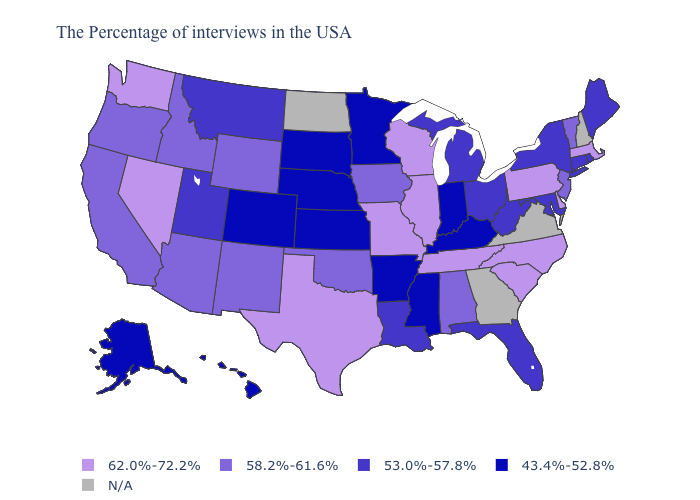Name the states that have a value in the range 58.2%-61.6%?
Be succinct. Vermont, New Jersey, Alabama, Iowa, Oklahoma, Wyoming, New Mexico, Arizona, Idaho, California, Oregon. What is the value of New York?
Give a very brief answer. 53.0%-57.8%. Among the states that border South Dakota , which have the lowest value?
Short answer required. Minnesota, Nebraska. Name the states that have a value in the range N/A?
Write a very short answer. New Hampshire, Virginia, Georgia, North Dakota. What is the value of Wyoming?
Short answer required. 58.2%-61.6%. What is the lowest value in states that border West Virginia?
Short answer required. 43.4%-52.8%. Among the states that border Tennessee , does Alabama have the highest value?
Be succinct. No. Among the states that border Vermont , which have the highest value?
Write a very short answer. Massachusetts. What is the value of West Virginia?
Concise answer only. 53.0%-57.8%. What is the value of South Carolina?
Be succinct. 62.0%-72.2%. Among the states that border Ohio , does Michigan have the lowest value?
Be succinct. No. What is the value of New Hampshire?
Be succinct. N/A. What is the value of Georgia?
Answer briefly. N/A. What is the value of Pennsylvania?
Write a very short answer. 62.0%-72.2%. 